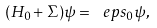Convert formula to latex. <formula><loc_0><loc_0><loc_500><loc_500>( H _ { 0 } + \Sigma ) \psi = \ e p s _ { 0 } \psi ,</formula> 